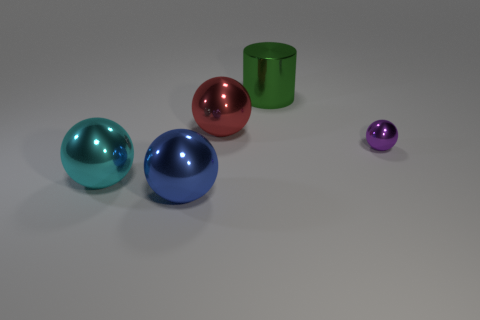Add 5 large blue metallic cylinders. How many objects exist? 10 Subtract all cylinders. How many objects are left? 4 Add 5 large green metallic objects. How many large green metallic objects exist? 6 Subtract 0 yellow cylinders. How many objects are left? 5 Subtract all tiny green metal things. Subtract all blue metallic balls. How many objects are left? 4 Add 1 cyan metallic objects. How many cyan metallic objects are left? 2 